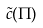Convert formula to latex. <formula><loc_0><loc_0><loc_500><loc_500>\tilde { c } ( \Pi )</formula> 